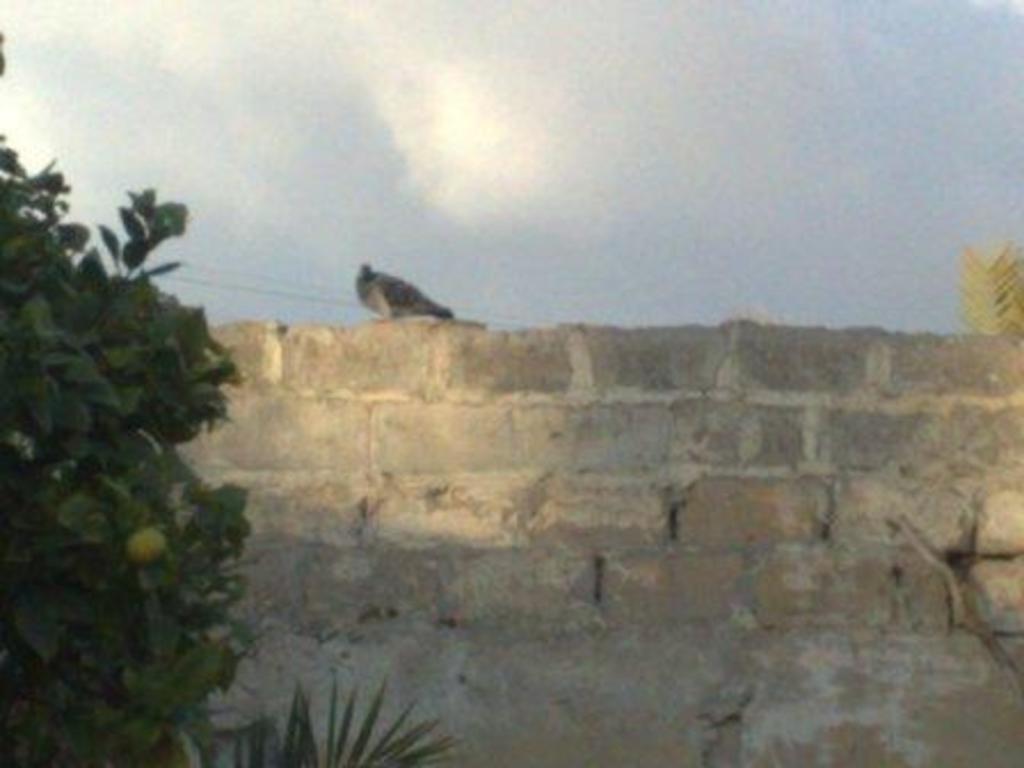Please provide a concise description of this image. On the left side, there is a tree having green color leaves. Beside this tree, there is a plant and there is a bird which is on a brick wall. In the background, there are clouds in the sky. 